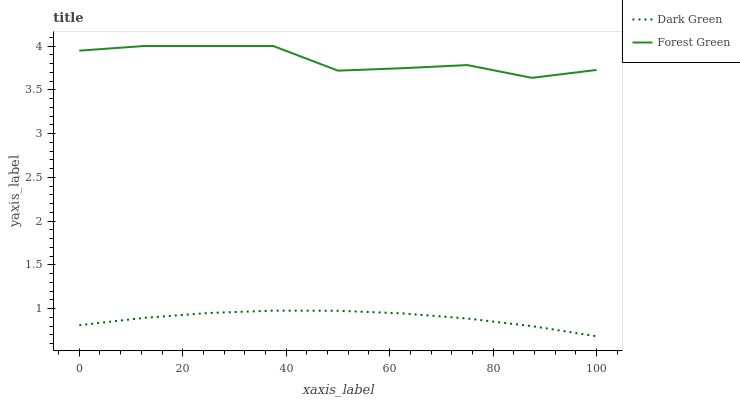Does Dark Green have the minimum area under the curve?
Answer yes or no. Yes. Does Forest Green have the maximum area under the curve?
Answer yes or no. Yes. Does Dark Green have the maximum area under the curve?
Answer yes or no. No. Is Dark Green the smoothest?
Answer yes or no. Yes. Is Forest Green the roughest?
Answer yes or no. Yes. Is Dark Green the roughest?
Answer yes or no. No. Does Dark Green have the lowest value?
Answer yes or no. Yes. Does Forest Green have the highest value?
Answer yes or no. Yes. Does Dark Green have the highest value?
Answer yes or no. No. Is Dark Green less than Forest Green?
Answer yes or no. Yes. Is Forest Green greater than Dark Green?
Answer yes or no. Yes. Does Dark Green intersect Forest Green?
Answer yes or no. No. 